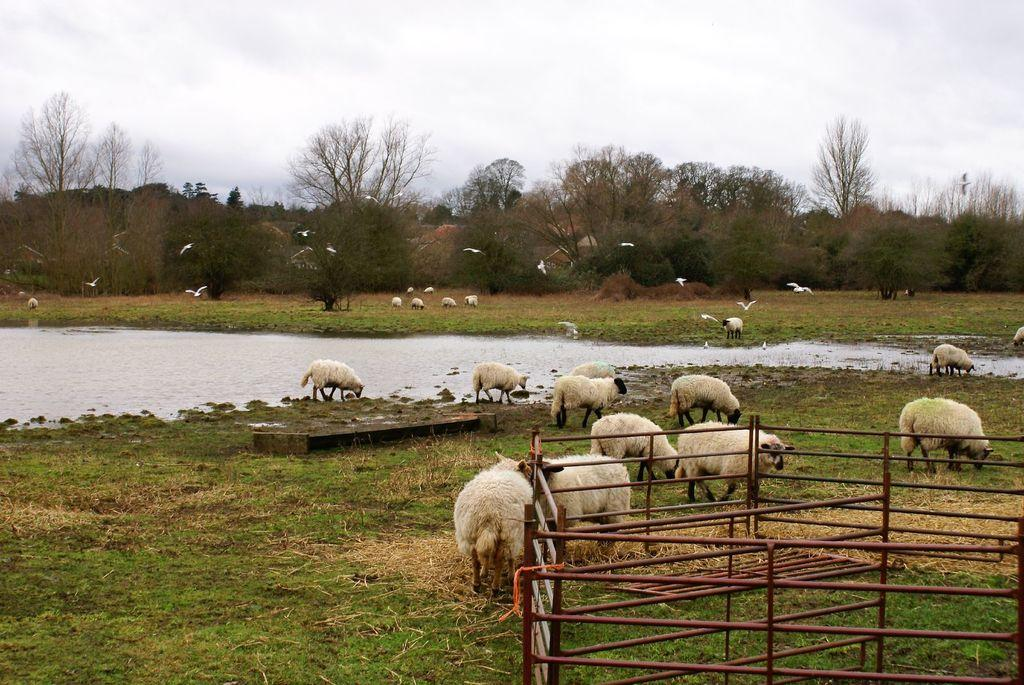What animals can be seen on the ground in the image? There are sheep on the ground in the image. What can be seen in the background of the image? Water, trees, and the sky are visible in the background of the image. What is the condition of the sky in the image? Clouds are observable in the sky. Where is the fencing located in the image? The fencing is in the bottom right corner of the image. What type of steel is used to construct the shelf in the image? There is no shelf present in the image, so it is not possible to determine the type of steel used for its construction. 